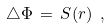<formula> <loc_0><loc_0><loc_500><loc_500>\triangle \Phi \, = \, S ( { r } ) \ ,</formula> 